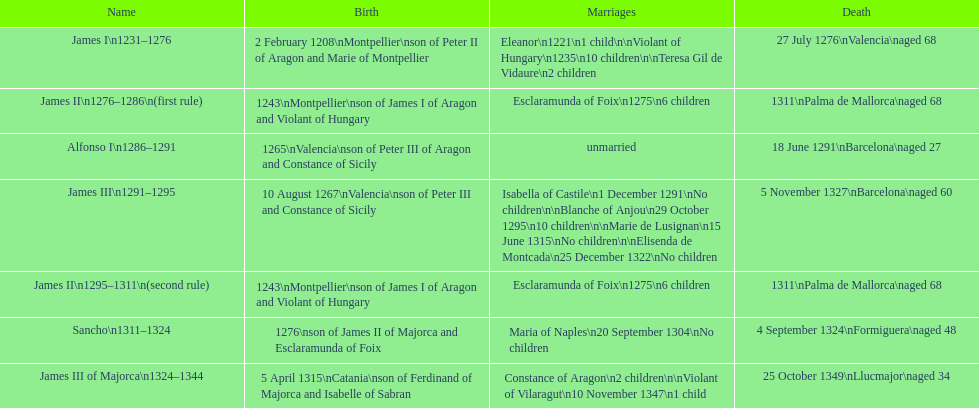How many of these monarchs died before the age of 65? 4. Parse the full table. {'header': ['Name', 'Birth', 'Marriages', 'Death'], 'rows': [['James I\\n1231–1276', '2 February 1208\\nMontpellier\\nson of Peter II of Aragon and Marie of Montpellier', 'Eleanor\\n1221\\n1 child\\n\\nViolant of Hungary\\n1235\\n10 children\\n\\nTeresa Gil de Vidaure\\n2 children', '27 July 1276\\nValencia\\naged 68'], ['James II\\n1276–1286\\n(first rule)', '1243\\nMontpellier\\nson of James I of Aragon and Violant of Hungary', 'Esclaramunda of Foix\\n1275\\n6 children', '1311\\nPalma de Mallorca\\naged 68'], ['Alfonso I\\n1286–1291', '1265\\nValencia\\nson of Peter III of Aragon and Constance of Sicily', 'unmarried', '18 June 1291\\nBarcelona\\naged 27'], ['James III\\n1291–1295', '10 August 1267\\nValencia\\nson of Peter III and Constance of Sicily', 'Isabella of Castile\\n1 December 1291\\nNo children\\n\\nBlanche of Anjou\\n29 October 1295\\n10 children\\n\\nMarie de Lusignan\\n15 June 1315\\nNo children\\n\\nElisenda de Montcada\\n25 December 1322\\nNo children', '5 November 1327\\nBarcelona\\naged 60'], ['James II\\n1295–1311\\n(second rule)', '1243\\nMontpellier\\nson of James I of Aragon and Violant of Hungary', 'Esclaramunda of Foix\\n1275\\n6 children', '1311\\nPalma de Mallorca\\naged 68'], ['Sancho\\n1311–1324', '1276\\nson of James II of Majorca and Esclaramunda of Foix', 'Maria of Naples\\n20 September 1304\\nNo children', '4 September 1324\\nFormiguera\\naged 48'], ['James III of Majorca\\n1324–1344', '5 April 1315\\nCatania\\nson of Ferdinand of Majorca and Isabelle of Sabran', 'Constance of Aragon\\n2 children\\n\\nViolant of Vilaragut\\n10 November 1347\\n1 child', '25 October 1349\\nLlucmajor\\naged 34']]} 